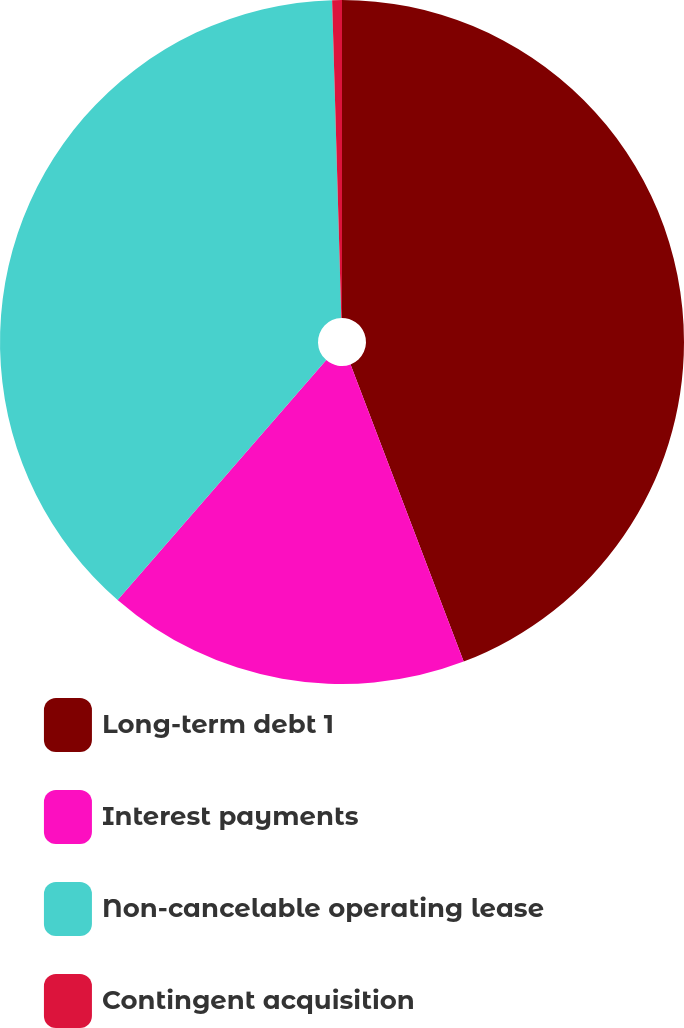<chart> <loc_0><loc_0><loc_500><loc_500><pie_chart><fcel>Long-term debt 1<fcel>Interest payments<fcel>Non-cancelable operating lease<fcel>Contingent acquisition<nl><fcel>44.21%<fcel>17.18%<fcel>38.15%<fcel>0.46%<nl></chart> 